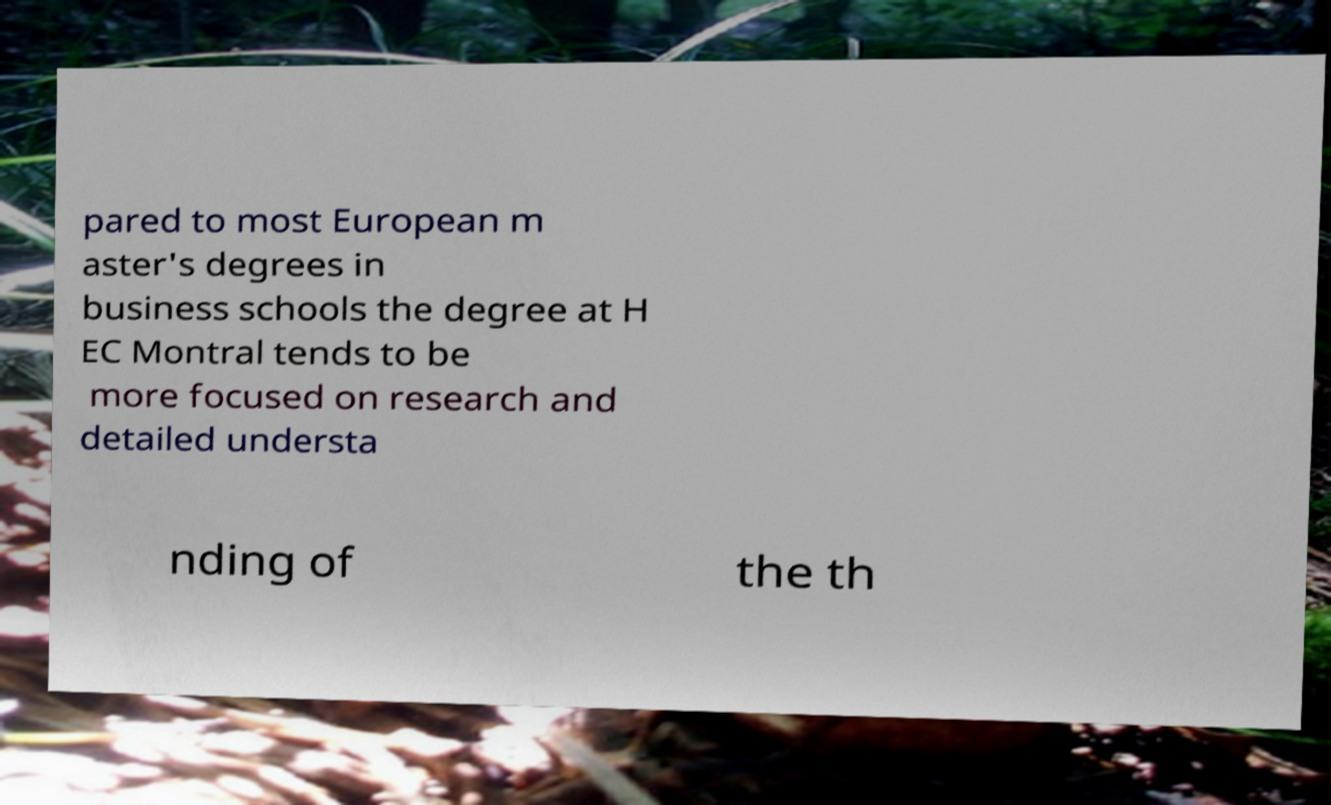There's text embedded in this image that I need extracted. Can you transcribe it verbatim? pared to most European m aster's degrees in business schools the degree at H EC Montral tends to be more focused on research and detailed understa nding of the th 